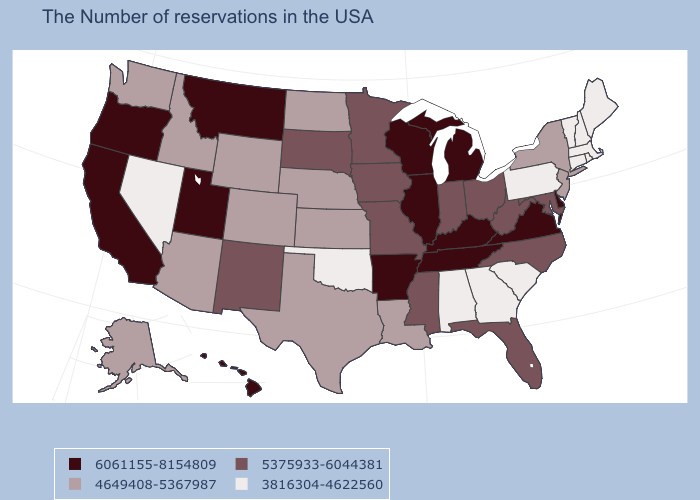Name the states that have a value in the range 4649408-5367987?
Quick response, please. New York, New Jersey, Louisiana, Kansas, Nebraska, Texas, North Dakota, Wyoming, Colorado, Arizona, Idaho, Washington, Alaska. Which states have the lowest value in the USA?
Give a very brief answer. Maine, Massachusetts, Rhode Island, New Hampshire, Vermont, Connecticut, Pennsylvania, South Carolina, Georgia, Alabama, Oklahoma, Nevada. Name the states that have a value in the range 3816304-4622560?
Be succinct. Maine, Massachusetts, Rhode Island, New Hampshire, Vermont, Connecticut, Pennsylvania, South Carolina, Georgia, Alabama, Oklahoma, Nevada. Name the states that have a value in the range 3816304-4622560?
Concise answer only. Maine, Massachusetts, Rhode Island, New Hampshire, Vermont, Connecticut, Pennsylvania, South Carolina, Georgia, Alabama, Oklahoma, Nevada. What is the lowest value in the USA?
Keep it brief. 3816304-4622560. Does New York have a higher value than Nebraska?
Quick response, please. No. What is the highest value in the USA?
Give a very brief answer. 6061155-8154809. Name the states that have a value in the range 5375933-6044381?
Keep it brief. Maryland, North Carolina, West Virginia, Ohio, Florida, Indiana, Mississippi, Missouri, Minnesota, Iowa, South Dakota, New Mexico. What is the lowest value in the USA?
Write a very short answer. 3816304-4622560. Does Oregon have the highest value in the USA?
Quick response, please. Yes. What is the lowest value in the South?
Quick response, please. 3816304-4622560. What is the highest value in the South ?
Be succinct. 6061155-8154809. Which states have the lowest value in the USA?
Give a very brief answer. Maine, Massachusetts, Rhode Island, New Hampshire, Vermont, Connecticut, Pennsylvania, South Carolina, Georgia, Alabama, Oklahoma, Nevada. What is the value of Oregon?
Answer briefly. 6061155-8154809. Does Mississippi have the lowest value in the USA?
Be succinct. No. 